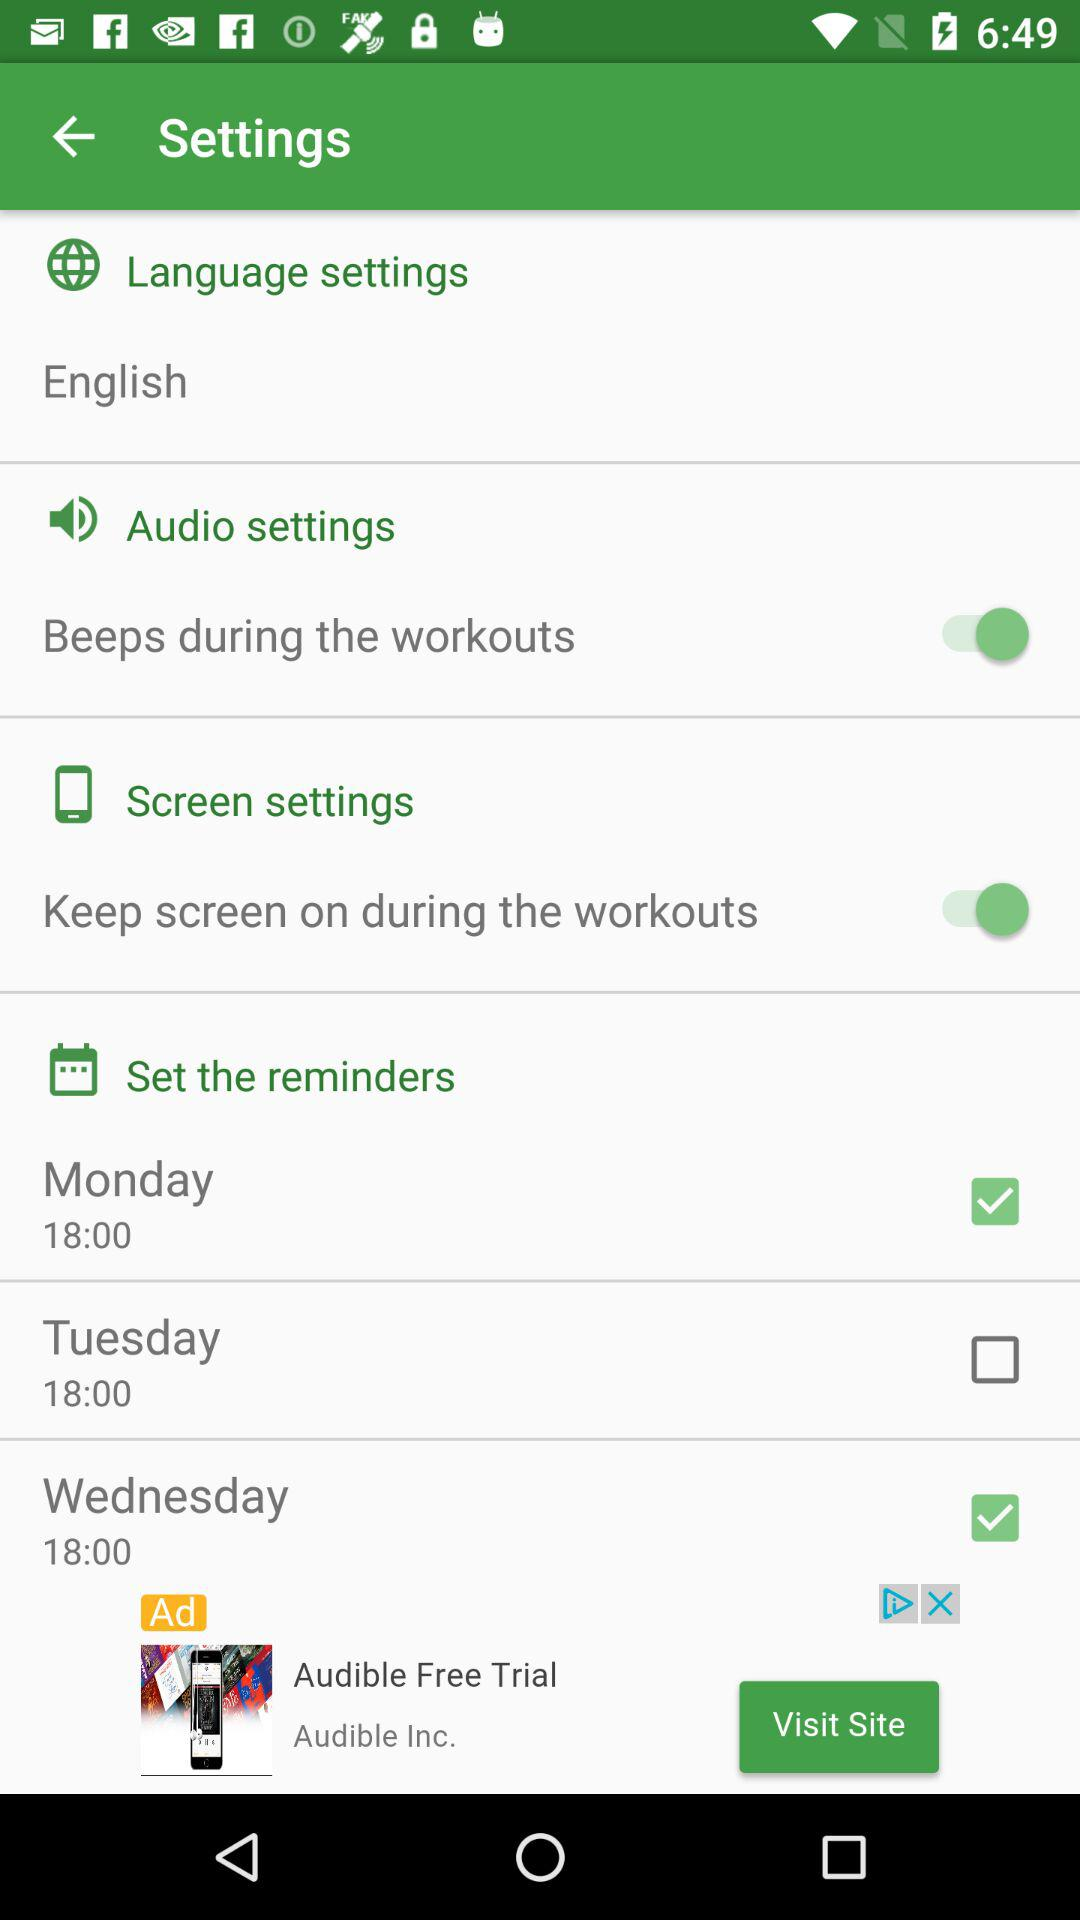How many settings are there?
Answer the question using a single word or phrase. 4 